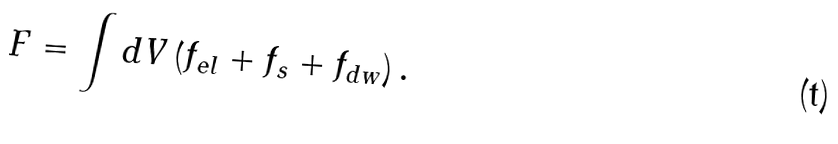Convert formula to latex. <formula><loc_0><loc_0><loc_500><loc_500>F = \int d V \left ( f _ { e l } + f _ { s } + f _ { d w } \right ) .</formula> 